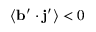<formula> <loc_0><loc_0><loc_500><loc_500>\langle { { b } ^ { \prime } \cdot { j } ^ { \prime } } \rangle < 0</formula> 